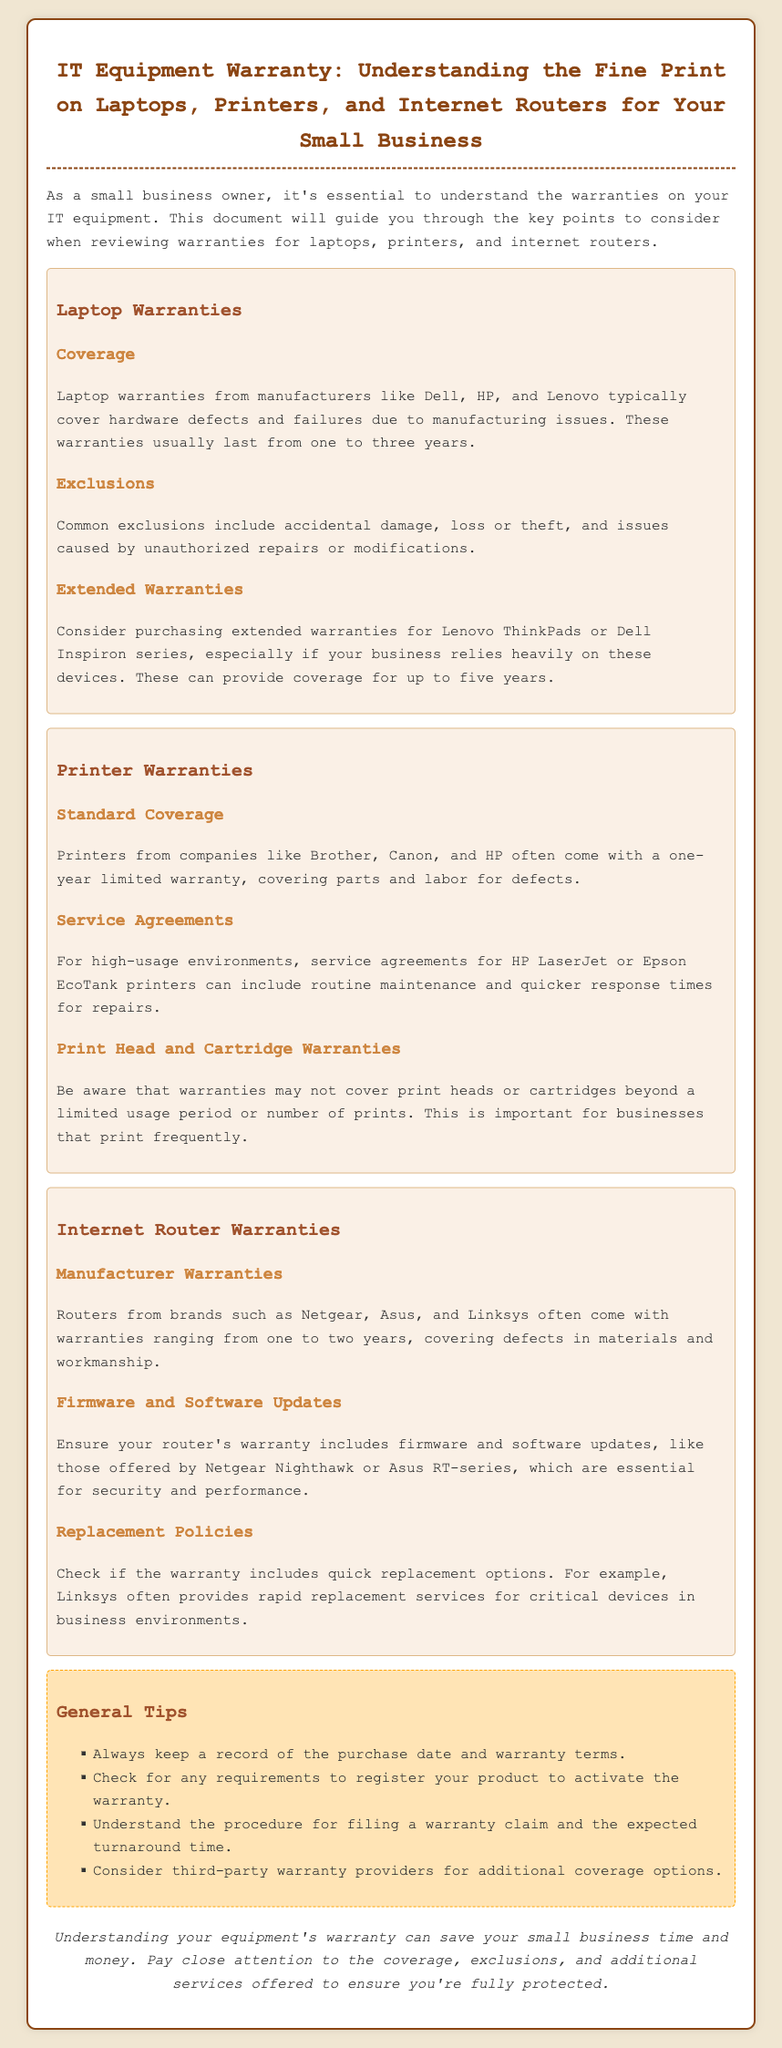What do laptop warranties typically cover? Laptop warranties typically cover hardware defects and failures due to manufacturing issues.
Answer: Hardware defects What is the exclusion related to unauthorized repairs? Unauthorized repairs or modifications are excluded from the warranty coverage.
Answer: Unauthorized repairs How long do standard printer warranties usually last? Standard printer warranties usually last one year.
Answer: One year What additional coverage should be considered for high-usage printers? Service agreements should be considered for high-usage printers.
Answer: Service agreements What is the warranty range for internet routers from brands like Linksys? The warranty range for internet routers is typically one to two years.
Answer: One to two years What should you keep a record of for warranties? You should keep a record of the purchase date and warranty terms.
Answer: Purchase date and warranty terms What type of devices do Dell Inspiron series warranties provide extended coverage for? Extended warranties provide coverage for Dell Inspiron series devices.
Answer: Dell Inspiron series What is important for businesses that print frequently regarding warranties? Warranties may not cover print heads or cartridges beyond a limited usage period.
Answer: Limited usage period 